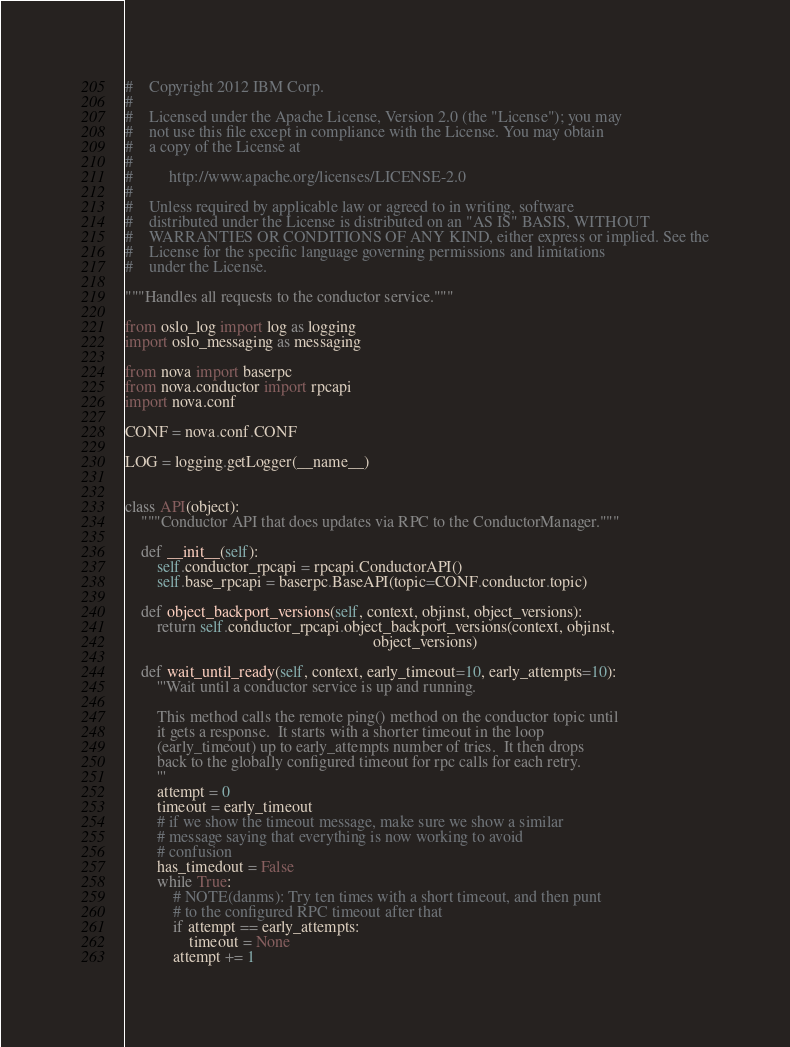Convert code to text. <code><loc_0><loc_0><loc_500><loc_500><_Python_>#    Copyright 2012 IBM Corp.
#
#    Licensed under the Apache License, Version 2.0 (the "License"); you may
#    not use this file except in compliance with the License. You may obtain
#    a copy of the License at
#
#         http://www.apache.org/licenses/LICENSE-2.0
#
#    Unless required by applicable law or agreed to in writing, software
#    distributed under the License is distributed on an "AS IS" BASIS, WITHOUT
#    WARRANTIES OR CONDITIONS OF ANY KIND, either express or implied. See the
#    License for the specific language governing permissions and limitations
#    under the License.

"""Handles all requests to the conductor service."""

from oslo_log import log as logging
import oslo_messaging as messaging

from nova import baserpc
from nova.conductor import rpcapi
import nova.conf

CONF = nova.conf.CONF

LOG = logging.getLogger(__name__)


class API(object):
    """Conductor API that does updates via RPC to the ConductorManager."""

    def __init__(self):
        self.conductor_rpcapi = rpcapi.ConductorAPI()
        self.base_rpcapi = baserpc.BaseAPI(topic=CONF.conductor.topic)

    def object_backport_versions(self, context, objinst, object_versions):
        return self.conductor_rpcapi.object_backport_versions(context, objinst,
                                                              object_versions)

    def wait_until_ready(self, context, early_timeout=10, early_attempts=10):
        '''Wait until a conductor service is up and running.

        This method calls the remote ping() method on the conductor topic until
        it gets a response.  It starts with a shorter timeout in the loop
        (early_timeout) up to early_attempts number of tries.  It then drops
        back to the globally configured timeout for rpc calls for each retry.
        '''
        attempt = 0
        timeout = early_timeout
        # if we show the timeout message, make sure we show a similar
        # message saying that everything is now working to avoid
        # confusion
        has_timedout = False
        while True:
            # NOTE(danms): Try ten times with a short timeout, and then punt
            # to the configured RPC timeout after that
            if attempt == early_attempts:
                timeout = None
            attempt += 1
</code> 